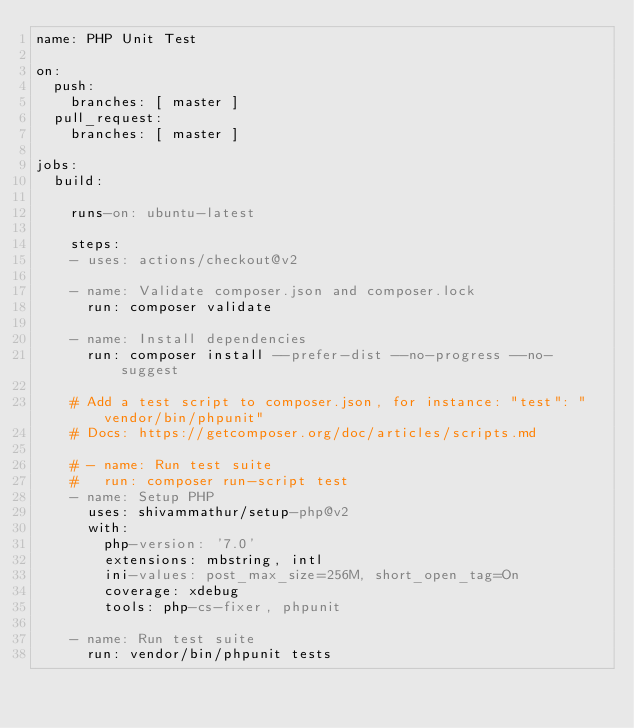Convert code to text. <code><loc_0><loc_0><loc_500><loc_500><_YAML_>name: PHP Unit Test

on:
  push:
    branches: [ master ]
  pull_request:
    branches: [ master ]

jobs:
  build:

    runs-on: ubuntu-latest

    steps:
    - uses: actions/checkout@v2

    - name: Validate composer.json and composer.lock
      run: composer validate

    - name: Install dependencies
      run: composer install --prefer-dist --no-progress --no-suggest

    # Add a test script to composer.json, for instance: "test": "vendor/bin/phpunit"
    # Docs: https://getcomposer.org/doc/articles/scripts.md

    # - name: Run test suite
    #   run: composer run-script test
    - name: Setup PHP
      uses: shivammathur/setup-php@v2
      with:
        php-version: '7.0'
        extensions: mbstring, intl
        ini-values: post_max_size=256M, short_open_tag=On
        coverage: xdebug    
        tools: php-cs-fixer, phpunit
    
    - name: Run test suite
      run: vendor/bin/phpunit tests
</code> 